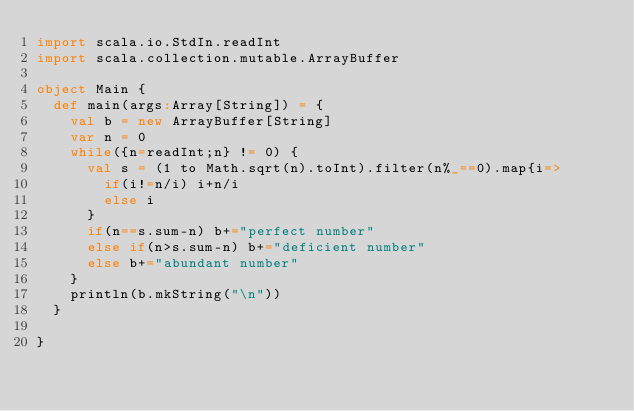<code> <loc_0><loc_0><loc_500><loc_500><_Scala_>import scala.io.StdIn.readInt
import scala.collection.mutable.ArrayBuffer

object Main {
  def main(args:Array[String]) = {
    val b = new ArrayBuffer[String]
    var n = 0
    while({n=readInt;n} != 0) {
      val s = (1 to Math.sqrt(n).toInt).filter(n%_==0).map{i=>
        if(i!=n/i) i+n/i
        else i
      }
      if(n==s.sum-n) b+="perfect number"
      else if(n>s.sum-n) b+="deficient number"
      else b+="abundant number"
    }
    println(b.mkString("\n"))
  }

}</code> 